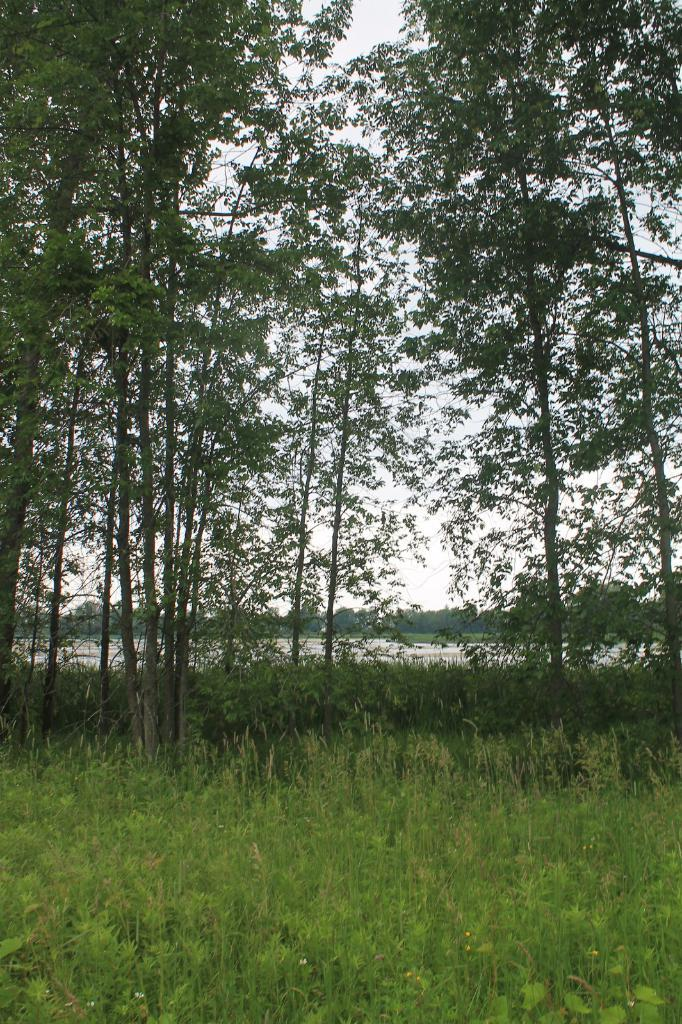What type of environment is depicted in the image? The image features greenery, suggesting a natural or outdoor setting. How many seats are available for people to sit on in the image? There is no information about seats or seating in the image, as it only mentions the presence of greenery. 